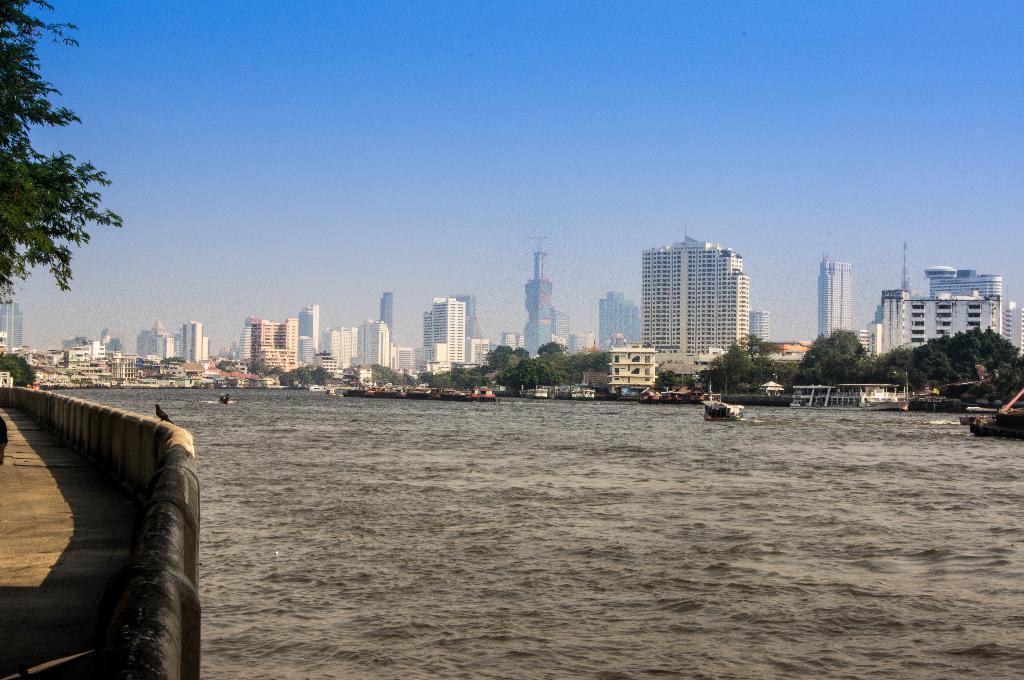In one or two sentences, can you explain what this image depicts? In this picture we can see few boats on the water, in the background we can find few buildings and trees. 